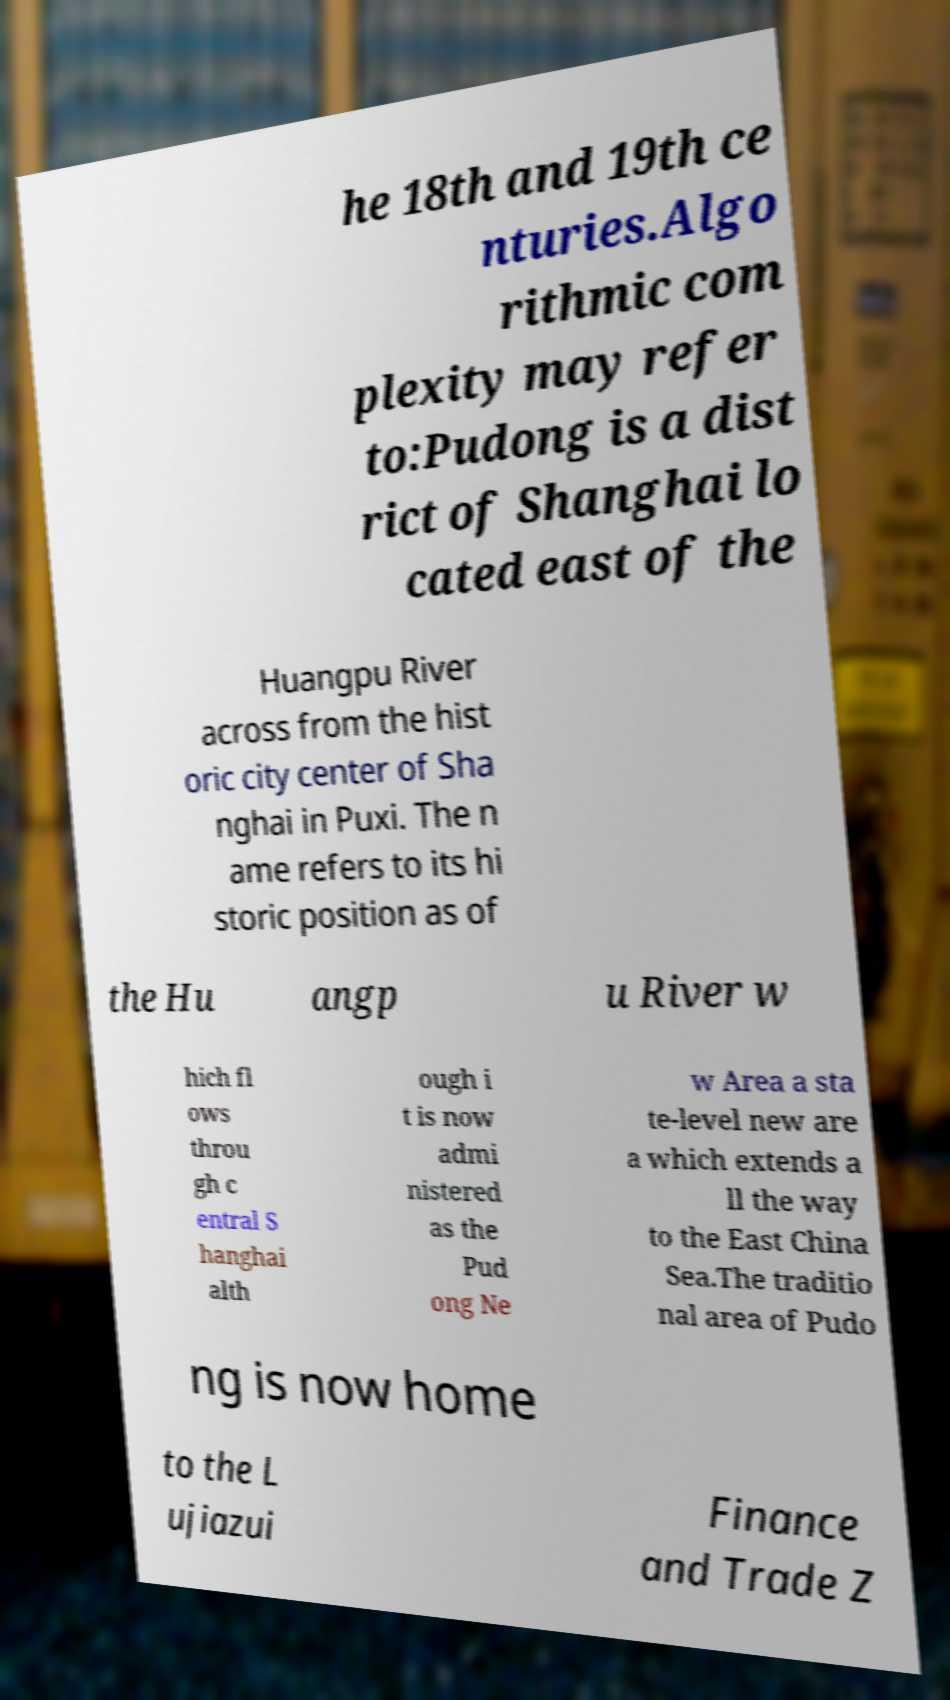Could you extract and type out the text from this image? he 18th and 19th ce nturies.Algo rithmic com plexity may refer to:Pudong is a dist rict of Shanghai lo cated east of the Huangpu River across from the hist oric city center of Sha nghai in Puxi. The n ame refers to its hi storic position as of the Hu angp u River w hich fl ows throu gh c entral S hanghai alth ough i t is now admi nistered as the Pud ong Ne w Area a sta te-level new are a which extends a ll the way to the East China Sea.The traditio nal area of Pudo ng is now home to the L ujiazui Finance and Trade Z 